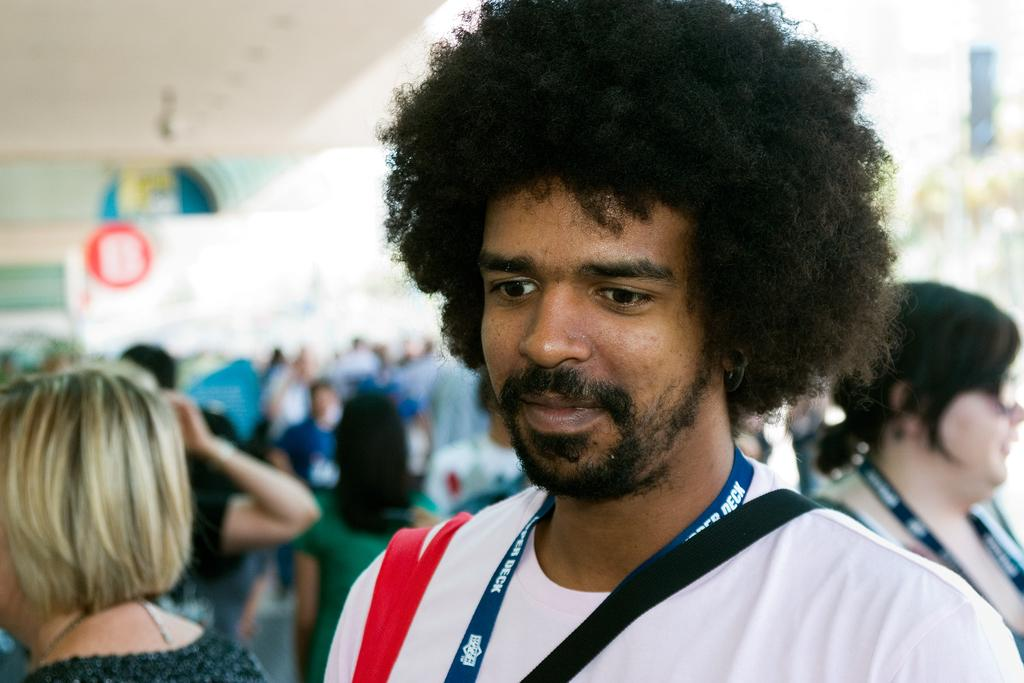What is the main subject of the image? There is a man standing in the image. What is the man's facial expression? The man is smiling. Are there any other people in the image? Yes, there are people standing behind the man. What can be seen at the top of the image? There is a roof visible at the top of the image. How many trees can be seen rubbing against each other in the image? There are no trees present in the image, so it is not possible to determine if any are rubbing against each other. 